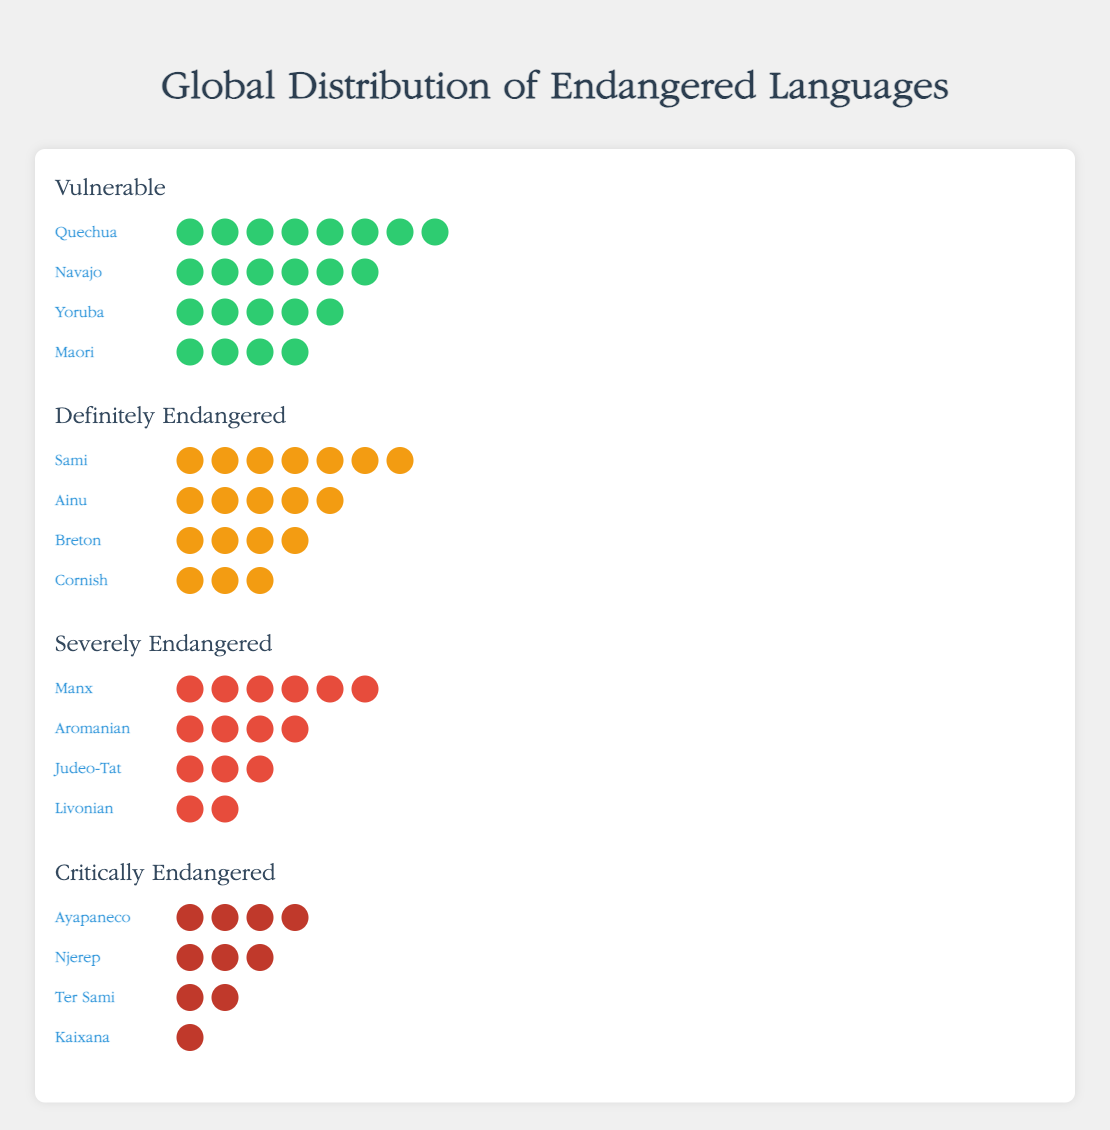What are the endangerment levels represented in the figure? The title of each section in the figure indicates an endangerment level: Vulnerable, Definitely Endangered, Severely Endangered, and Critically Endangered. These titles are visually emphatic and clearly separated.
Answer: Vulnerable, Definitely Endangered, Severely Endangered, Critically Endangered Which language has the highest count under the "Definitely Endangered" category? Looking at the section labeled "Definitely Endangered," the language with the most icons is Sami, which has 7 icons.
Answer: Sami How many languages are listed under the "Severely Endangered" category? The "Severely Endangered" section has four rows, each representing a different language: Manx, Aromanian, Judeo-Tat, and Livonian.
Answer: 4 How many total languages are represented across all endangerment levels? Count the total number of languages listed in each endangerment level section: Vulnerable (4), Definitely Endangered (4), Severely Endangered (4), Critically Endangered (4). The sum is 4 + 4 + 4 + 4.
Answer: 16 Which categories have languages with a count greater than or equal to 6? Check each category for languages with a count of 6 or more: Quechua and Navajo in Vulnerable, Sami in Definitely Endangered, and Manx in Severely Endangered all have counts >= 6.
Answer: Vulnerable, Definitely Endangered, Severely Endangered Compare the total counts of languages in the "Vulnerable" and "Critically Endangered" categories. Which has fewer total language counts? Summing the counts in each level: Vulnerable (8 + 6 + 5 + 4 = 23), Critically Endangered (4 + 3 + 2 + 1 = 10). Critically Endangered has fewer.
Answer: Critically Endangered What is the difference in language counts between "Judeo-Tat" and "Livonian" in the "Severely Endangered" category? The counts are 3 for Judeo-Tat and 2 for Livonian. The difference is 3 - 2.
Answer: 1 Which two languages have the same count under the "Definitely Endangered" category? Ainu and Sami and Breton have counts of 5, and Cornish has a count of 3. Breton and Ainu both have counts greater than 3.
Answer: Breton and Ainu 